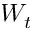Convert formula to latex. <formula><loc_0><loc_0><loc_500><loc_500>W _ { t }</formula> 